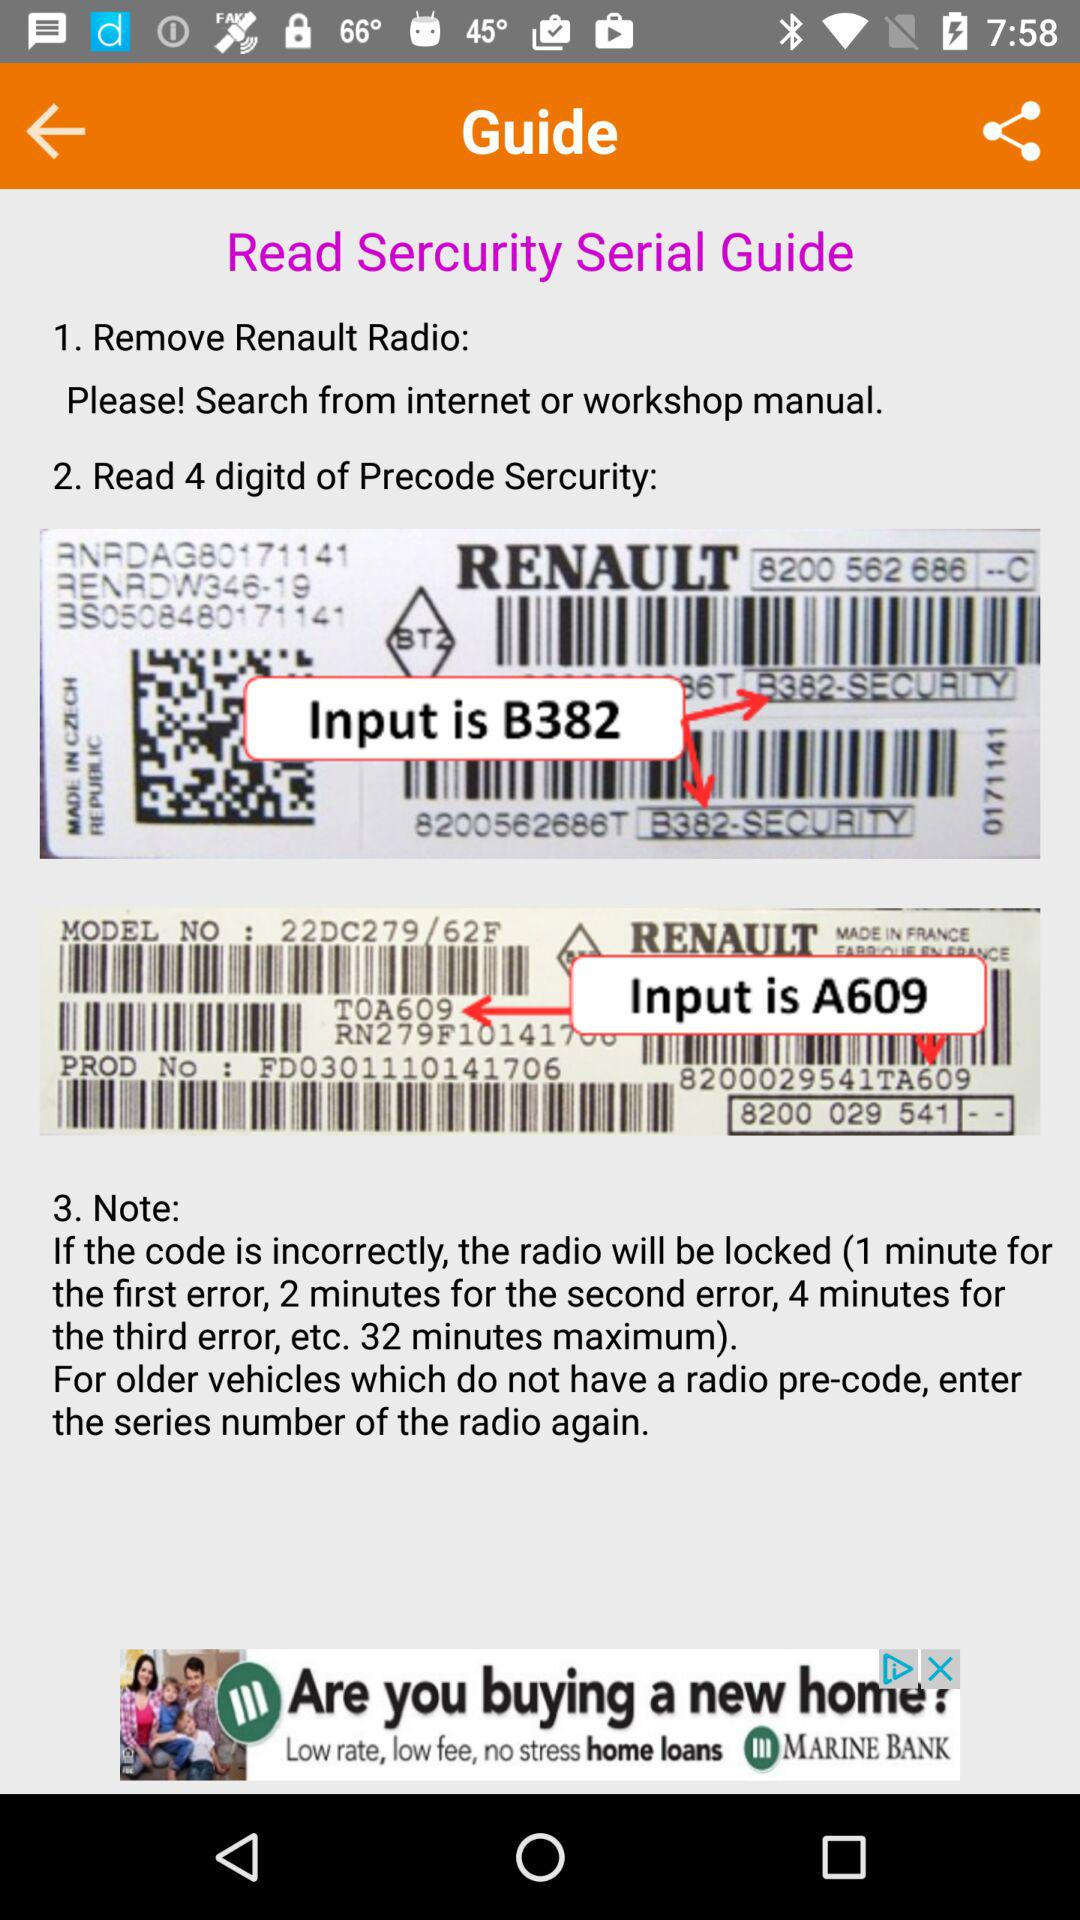How many digits are there in the radio code?
Answer the question using a single word or phrase. 4 